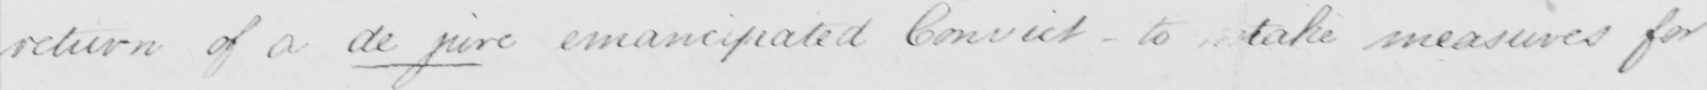Can you read and transcribe this handwriting? return of a de jure emancipated Convict _ to take measures for 